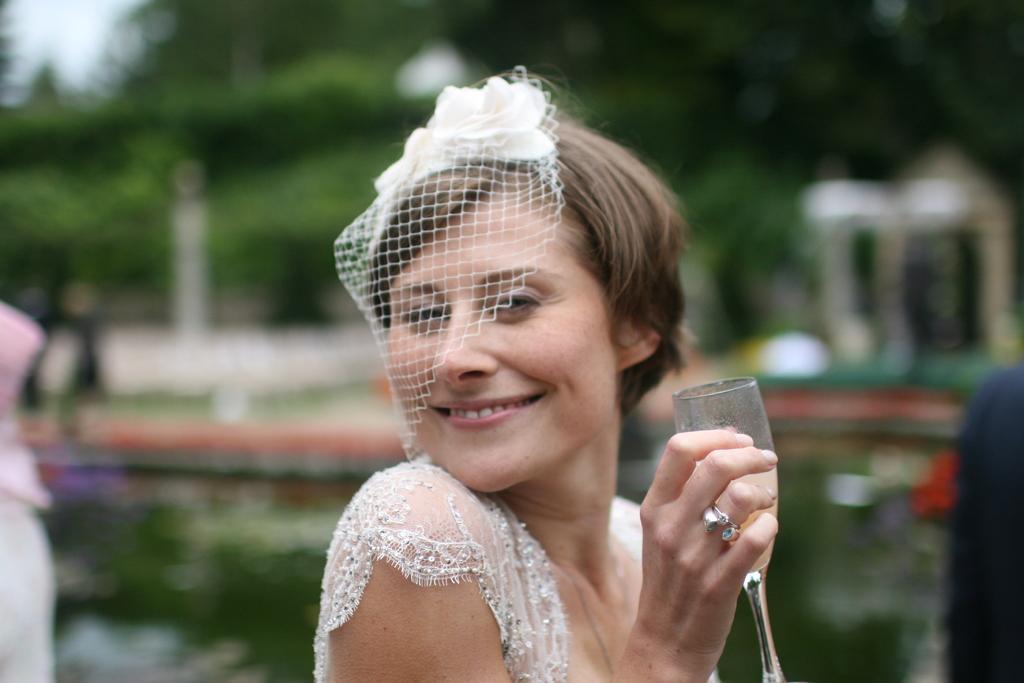How would you summarize this image in a sentence or two? This Picture describe about the beautiful woman wearing white dress and a neat cap on her head, Holding a glass of wine in her hand and giving the smile in the camera. Behind we can see some plants and water lake. 